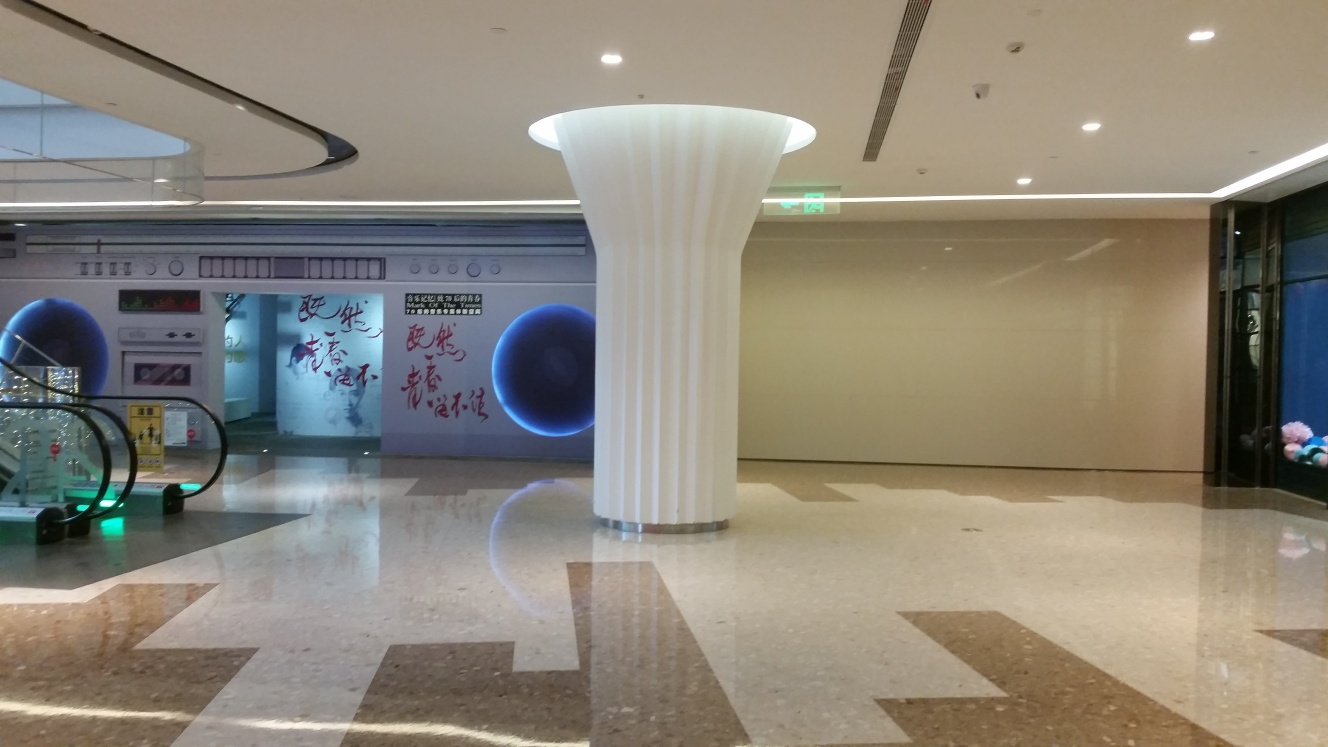Is the image too dark?
 No 